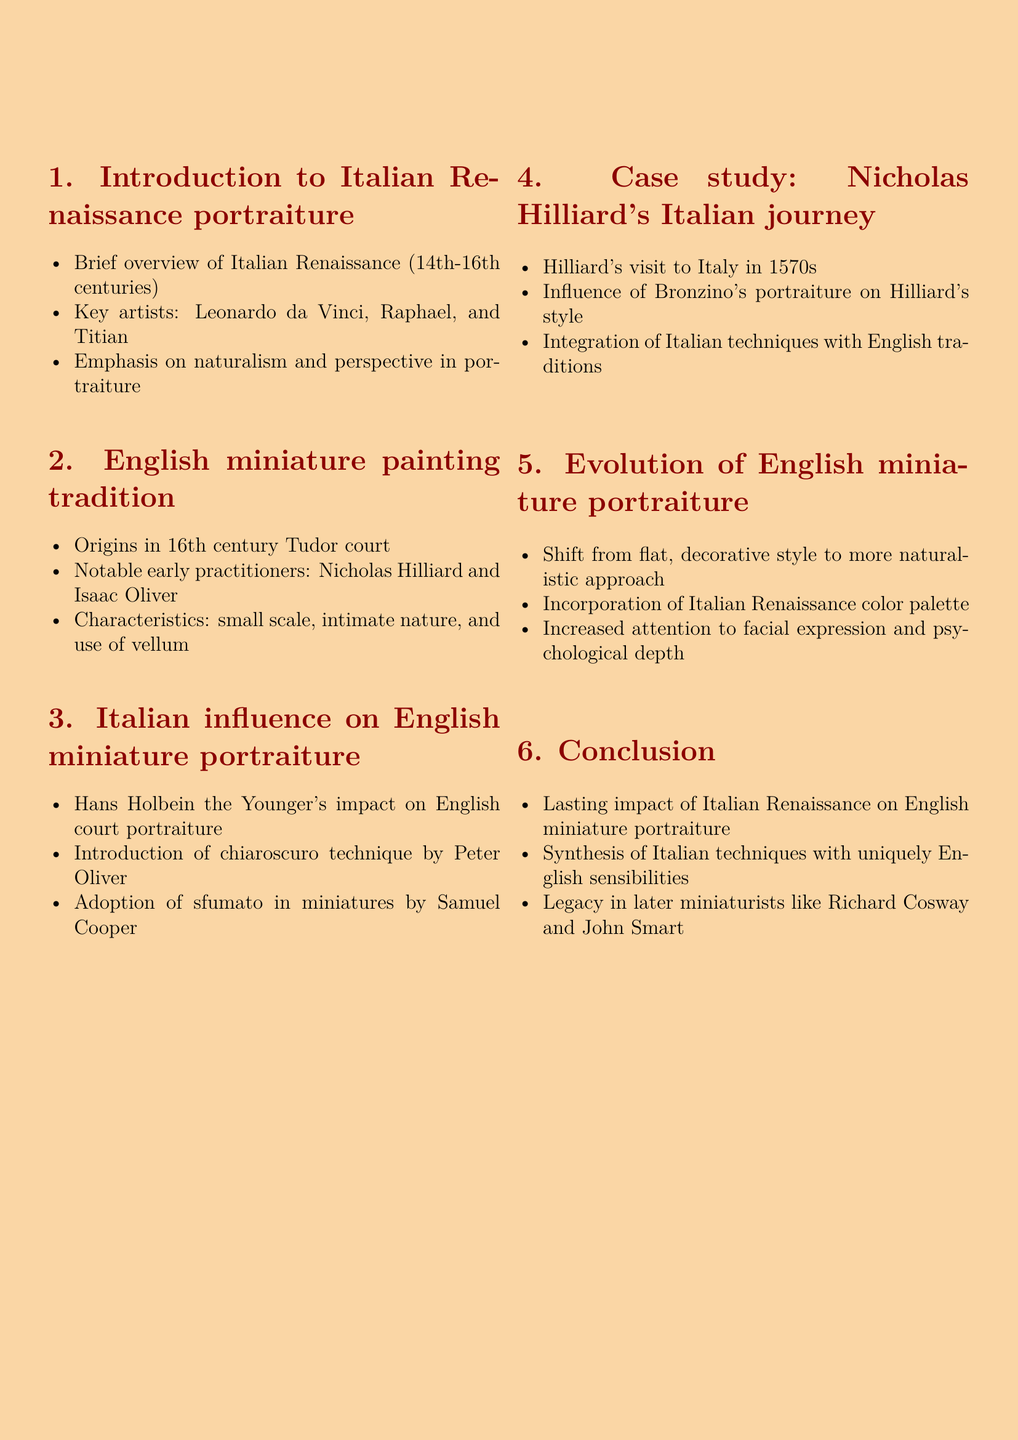What is the title of the lecture? The title is explicitly mentioned at the beginning of the document.
Answer: The Influence of Italian Renaissance Artists on English Miniature Portraiture Who are three key artists mentioned in the introduction? The document lists these artists in connection with the Italian Renaissance.
Answer: Leonardo da Vinci, Raphael, and Titian Which century marks the origins of English miniature painting tradition? The document specifies the century in which this tradition began.
Answer: 16th century What technique was introduced by Peter Oliver? The document mentions this specific technique under Italian influence.
Answer: Chiaroscuro Who was notably influenced by Bronzino's portraiture? The document attributes this influence to a specific artist in the case study.
Answer: Nicholas Hilliard What shift occurred in the evolution of English miniature portraiture? The document discusses a significant change in style.
Answer: From flat, decorative style to more naturalistic approach Which two later miniaturists are mentioned in the conclusion? The document specifies the legacy of certain artists following the synthesis of styles.
Answer: Richard Cosway and John Smart 